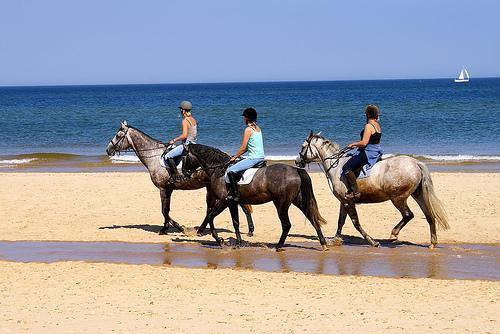How many animals are pictured?
Give a very brief answer. 3. 